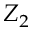Convert formula to latex. <formula><loc_0><loc_0><loc_500><loc_500>Z _ { 2 }</formula> 